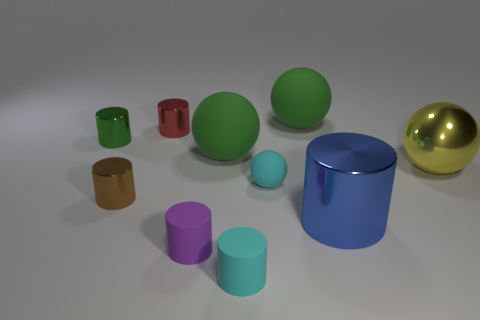Can you describe the atmosphere or mood that this arrangement of objects might evoke? The arrangement of objects, with its clean lines and bright, distinct colors, evokes a sense of order and calm. It has a minimalist aesthetic that could suggest a modern, controlled environment. The simplicity and clarity of the scene might also promote focus and clarity of thought. 